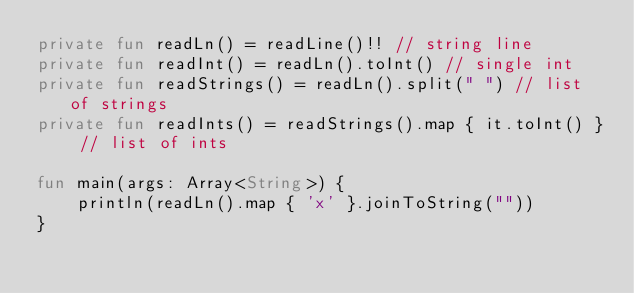<code> <loc_0><loc_0><loc_500><loc_500><_Kotlin_>private fun readLn() = readLine()!! // string line
private fun readInt() = readLn().toInt() // single int
private fun readStrings() = readLn().split(" ") // list of strings
private fun readInts() = readStrings().map { it.toInt() } // list of ints

fun main(args: Array<String>) {
    println(readLn().map { 'x' }.joinToString(""))
}</code> 